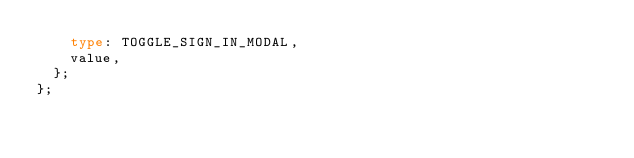<code> <loc_0><loc_0><loc_500><loc_500><_TypeScript_>    type: TOGGLE_SIGN_IN_MODAL,
    value,
  };
};
</code> 